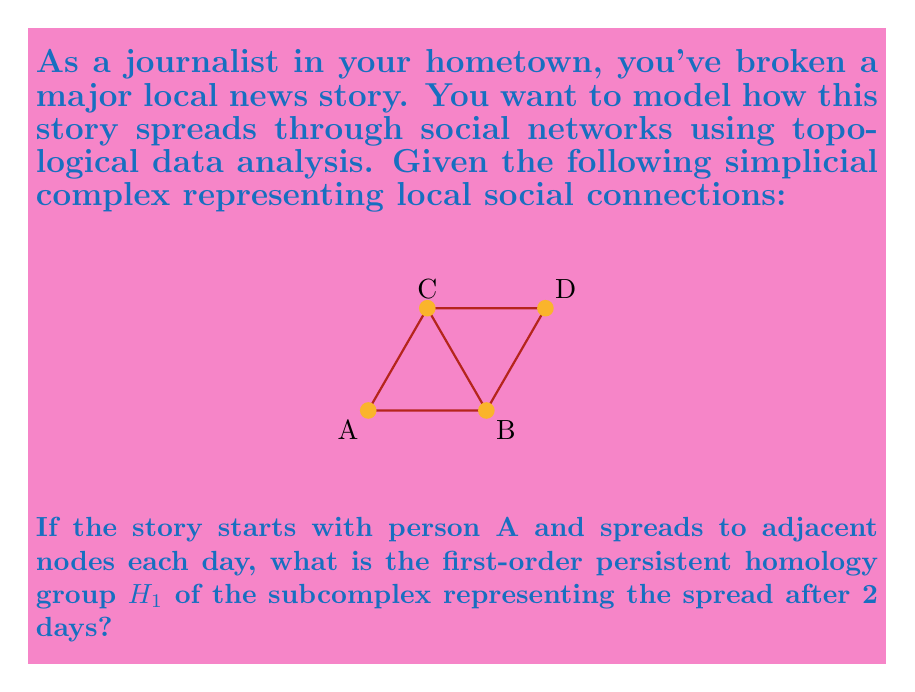Teach me how to tackle this problem. Let's approach this step-by-step:

1) First, we need to understand how the story spreads:
   - Day 0: Only A has the story
   - Day 1: A, B, and C have the story
   - Day 2: A, B, C, and D have the story (the entire complex)

2) After 2 days, the subcomplex representing the spread is the entire complex shown in the diagram.

3) To calculate the first-order persistent homology group $H_1$, we need to:
   a) Identify 1-dimensional cycles (loops)
   b) Determine which of these cycles are not boundaries of 2-dimensional simplices

4) In this complex:
   - There is one 1-dimensional cycle: the triangle ABC
   - This cycle is the boundary of the 2-dimensional simplex ABC

5) Since the only 1-dimensional cycle is a boundary, the first-order homology group $H_1$ is trivial.

6) In topological notation, we express this as:

   $$H_1 \cong 0$$

   Where $0$ represents the trivial group with only the identity element.
Answer: $H_1 \cong 0$ 